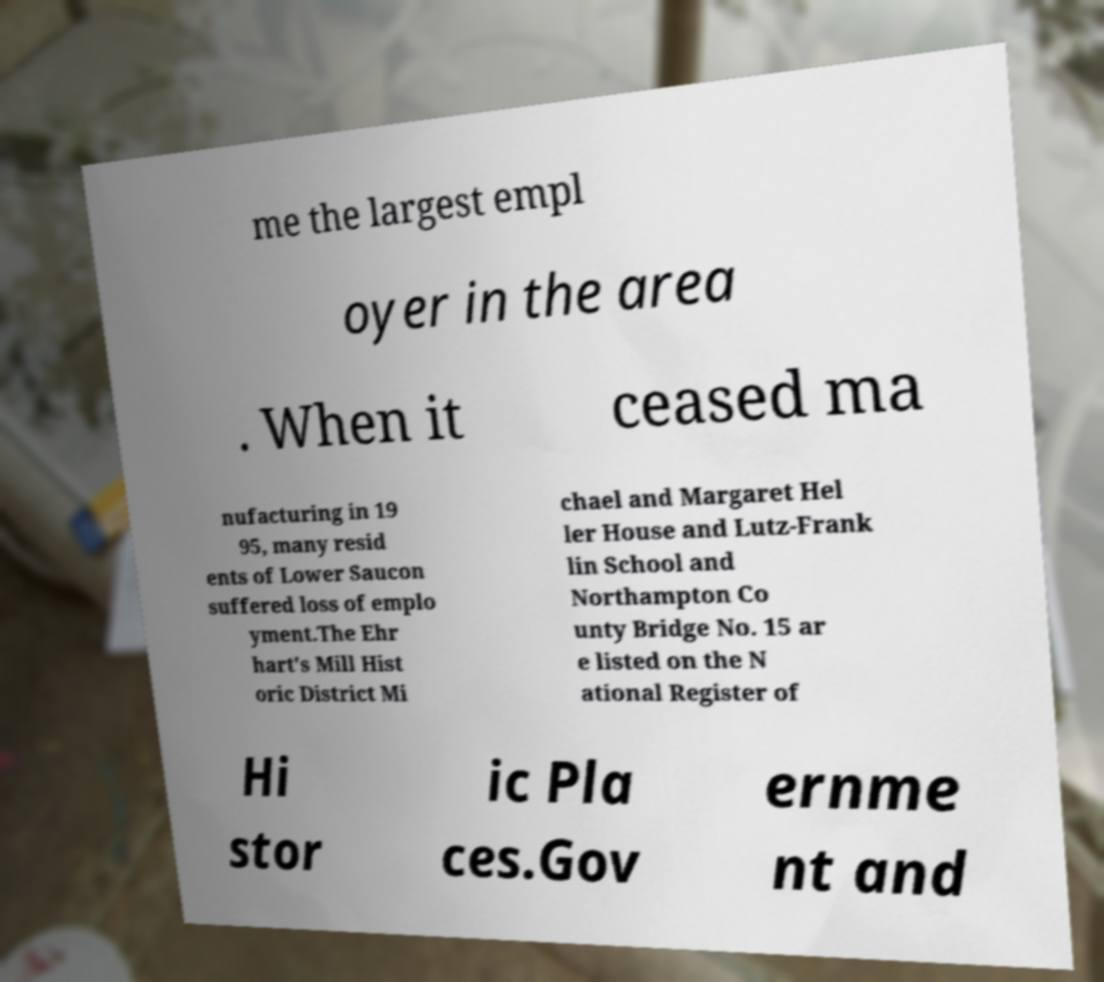Could you extract and type out the text from this image? me the largest empl oyer in the area . When it ceased ma nufacturing in 19 95, many resid ents of Lower Saucon suffered loss of emplo yment.The Ehr hart's Mill Hist oric District Mi chael and Margaret Hel ler House and Lutz-Frank lin School and Northampton Co unty Bridge No. 15 ar e listed on the N ational Register of Hi stor ic Pla ces.Gov ernme nt and 